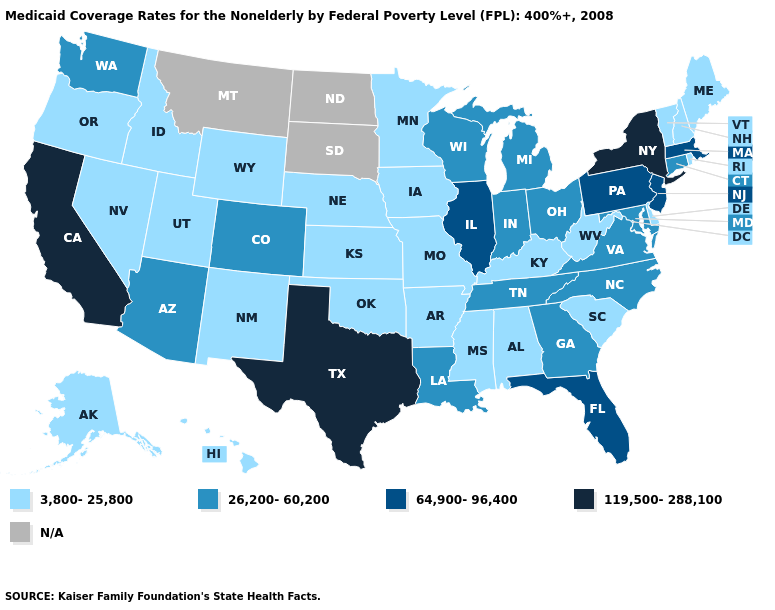Which states hav the highest value in the South?
Keep it brief. Texas. What is the value of Louisiana?
Quick response, please. 26,200-60,200. Name the states that have a value in the range 3,800-25,800?
Concise answer only. Alabama, Alaska, Arkansas, Delaware, Hawaii, Idaho, Iowa, Kansas, Kentucky, Maine, Minnesota, Mississippi, Missouri, Nebraska, Nevada, New Hampshire, New Mexico, Oklahoma, Oregon, Rhode Island, South Carolina, Utah, Vermont, West Virginia, Wyoming. Name the states that have a value in the range 64,900-96,400?
Keep it brief. Florida, Illinois, Massachusetts, New Jersey, Pennsylvania. Among the states that border Oregon , which have the highest value?
Quick response, please. California. Which states have the highest value in the USA?
Concise answer only. California, New York, Texas. Name the states that have a value in the range N/A?
Quick response, please. Montana, North Dakota, South Dakota. What is the highest value in states that border Maryland?
Keep it brief. 64,900-96,400. What is the value of West Virginia?
Keep it brief. 3,800-25,800. Does Wyoming have the highest value in the West?
Answer briefly. No. What is the value of Kansas?
Short answer required. 3,800-25,800. Is the legend a continuous bar?
Short answer required. No. What is the value of Maryland?
Quick response, please. 26,200-60,200. 